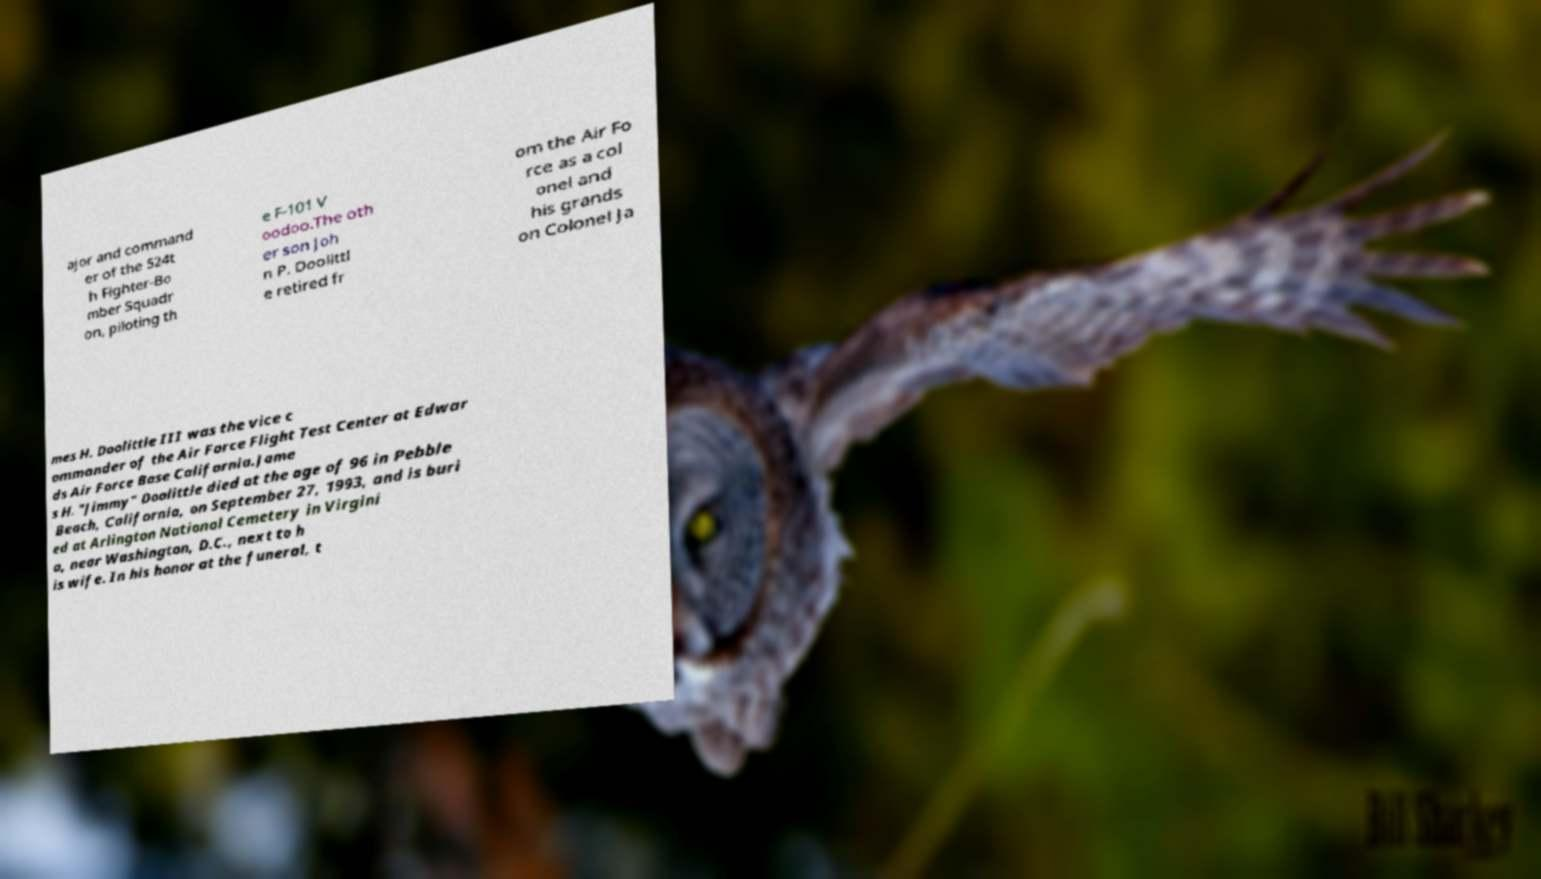Could you extract and type out the text from this image? ajor and command er of the 524t h Fighter-Bo mber Squadr on, piloting th e F-101 V oodoo.The oth er son Joh n P. Doolittl e retired fr om the Air Fo rce as a col onel and his grands on Colonel Ja mes H. Doolittle III was the vice c ommander of the Air Force Flight Test Center at Edwar ds Air Force Base California.Jame s H. "Jimmy" Doolittle died at the age of 96 in Pebble Beach, California, on September 27, 1993, and is buri ed at Arlington National Cemetery in Virgini a, near Washington, D.C., next to h is wife. In his honor at the funeral, t 